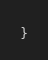<code> <loc_0><loc_0><loc_500><loc_500><_TypeScript_>}
</code> 